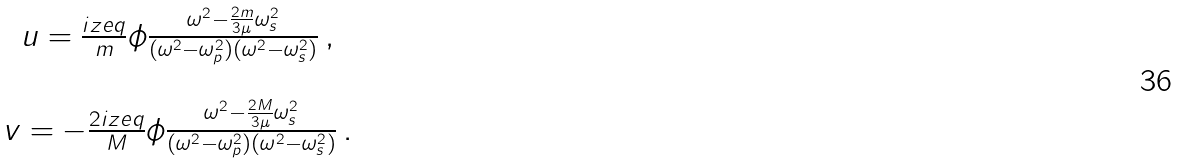<formula> <loc_0><loc_0><loc_500><loc_500>\begin{array} { c } u = \frac { i z e q } { m } \phi \frac { \omega ^ { 2 } - \frac { 2 m } { 3 \mu } \omega _ { s } ^ { 2 } } { ( \omega ^ { 2 } - \omega _ { p } ^ { 2 } ) ( \omega ^ { 2 } - \omega _ { s } ^ { 2 } ) } \, , \\ \\ v = - \frac { 2 i z e q } { M } \phi \frac { \omega ^ { 2 } - \frac { 2 M } { 3 \mu } \omega _ { s } ^ { 2 } } { ( \omega ^ { 2 } - \omega _ { p } ^ { 2 } ) ( \omega ^ { 2 } - \omega _ { s } ^ { 2 } ) } \, . \end{array}</formula> 